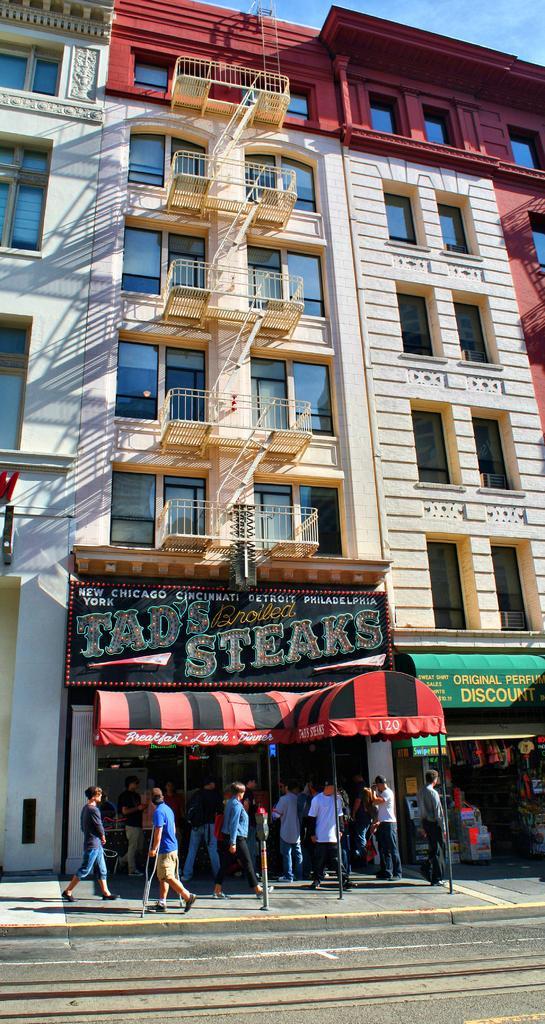Can you describe this image briefly? In this image, I can see the buildings with the windows and name boards. I can see a group of people walking on the pathway. This is the road. This is the kind of a tent. 